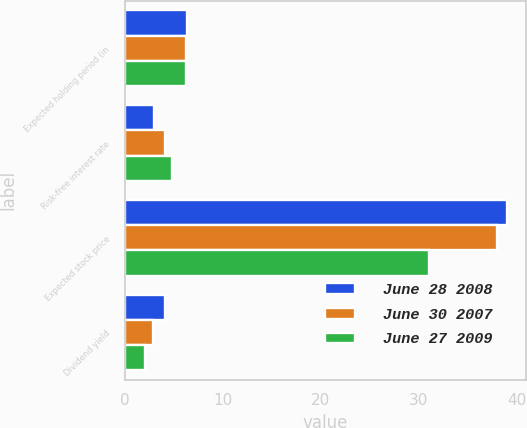Convert chart to OTSL. <chart><loc_0><loc_0><loc_500><loc_500><stacked_bar_chart><ecel><fcel>Expected holding period (in<fcel>Risk-free interest rate<fcel>Expected stock price<fcel>Dividend yield<nl><fcel>June 28 2008<fcel>6.3<fcel>3<fcel>39<fcel>4.1<nl><fcel>June 30 2007<fcel>6.2<fcel>4.1<fcel>38<fcel>2.9<nl><fcel>June 27 2009<fcel>6.2<fcel>4.8<fcel>31<fcel>2<nl></chart> 